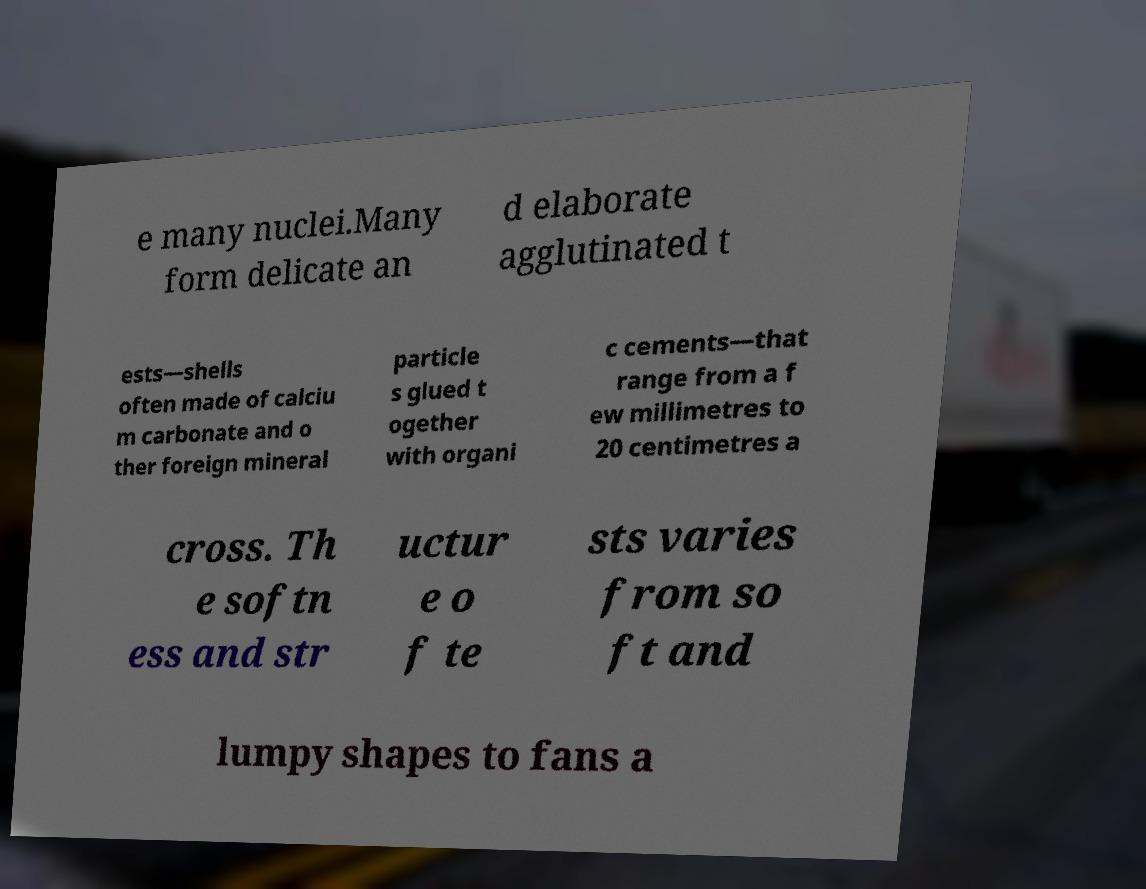What messages or text are displayed in this image? I need them in a readable, typed format. e many nuclei.Many form delicate an d elaborate agglutinated t ests—shells often made of calciu m carbonate and o ther foreign mineral particle s glued t ogether with organi c cements—that range from a f ew millimetres to 20 centimetres a cross. Th e softn ess and str uctur e o f te sts varies from so ft and lumpy shapes to fans a 